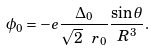Convert formula to latex. <formula><loc_0><loc_0><loc_500><loc_500>\phi _ { 0 } = - e \frac { \Delta _ { 0 } } { \sqrt { 2 } \ r _ { 0 } } \frac { \sin \theta } { R ^ { 3 } } .</formula> 